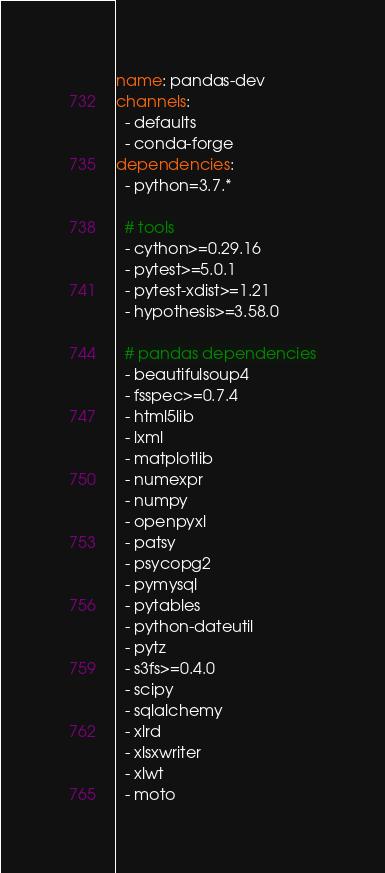<code> <loc_0><loc_0><loc_500><loc_500><_YAML_>name: pandas-dev
channels:
  - defaults
  - conda-forge
dependencies:
  - python=3.7.*

  # tools
  - cython>=0.29.16
  - pytest>=5.0.1
  - pytest-xdist>=1.21
  - hypothesis>=3.58.0

  # pandas dependencies
  - beautifulsoup4
  - fsspec>=0.7.4
  - html5lib
  - lxml
  - matplotlib
  - numexpr
  - numpy
  - openpyxl
  - patsy
  - psycopg2
  - pymysql
  - pytables
  - python-dateutil
  - pytz
  - s3fs>=0.4.0
  - scipy
  - sqlalchemy
  - xlrd
  - xlsxwriter
  - xlwt
  - moto
</code> 